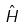Convert formula to latex. <formula><loc_0><loc_0><loc_500><loc_500>\hat { H }</formula> 